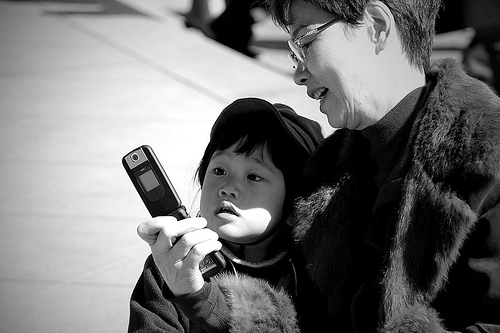What emotions do you think are associated with this image? The image seems to evoke a sense of curiosity and bonding. It's a candid capture of an everyday moment where technology bridges generations, potentially creating a shared experience or learning opportunity. 